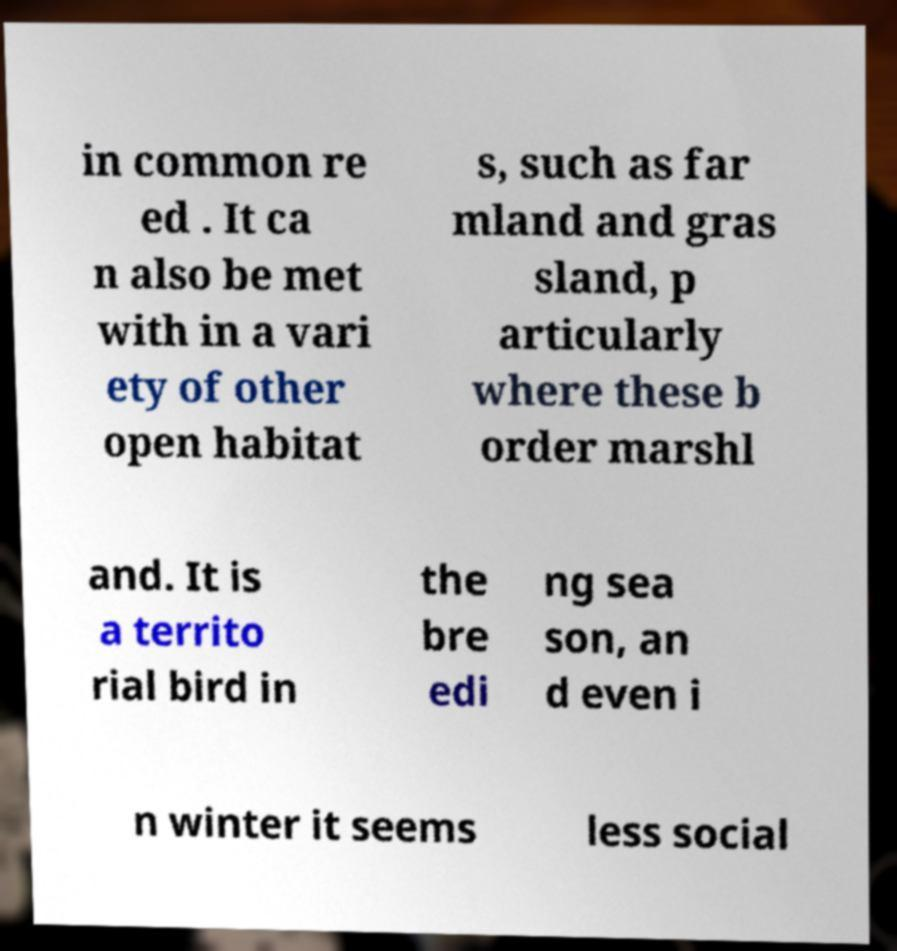Please read and relay the text visible in this image. What does it say? in common re ed . It ca n also be met with in a vari ety of other open habitat s, such as far mland and gras sland, p articularly where these b order marshl and. It is a territo rial bird in the bre edi ng sea son, an d even i n winter it seems less social 